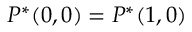Convert formula to latex. <formula><loc_0><loc_0><loc_500><loc_500>P ^ { * } ( 0 , 0 ) = P ^ { * } ( 1 , 0 )</formula> 